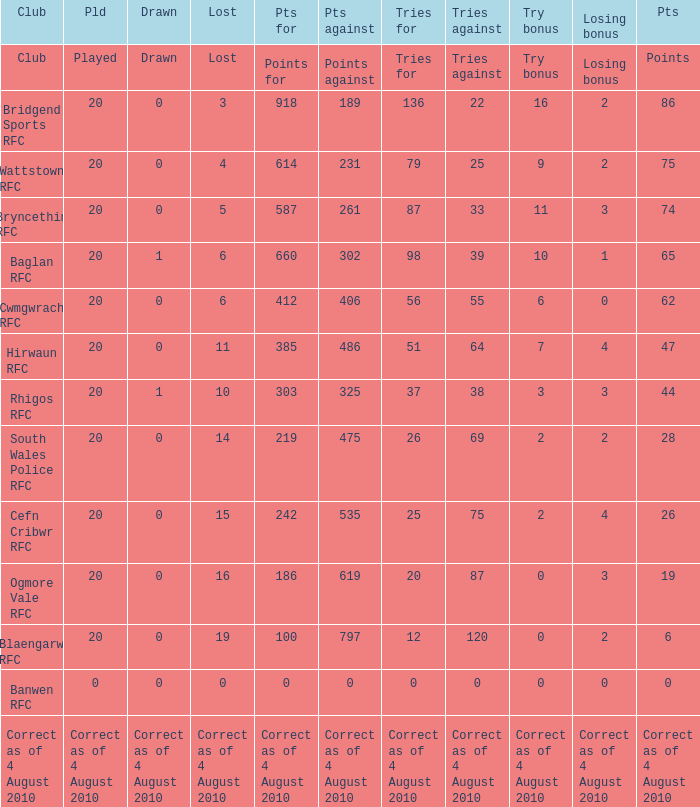What is lost when the points against is 231? 4.0. 